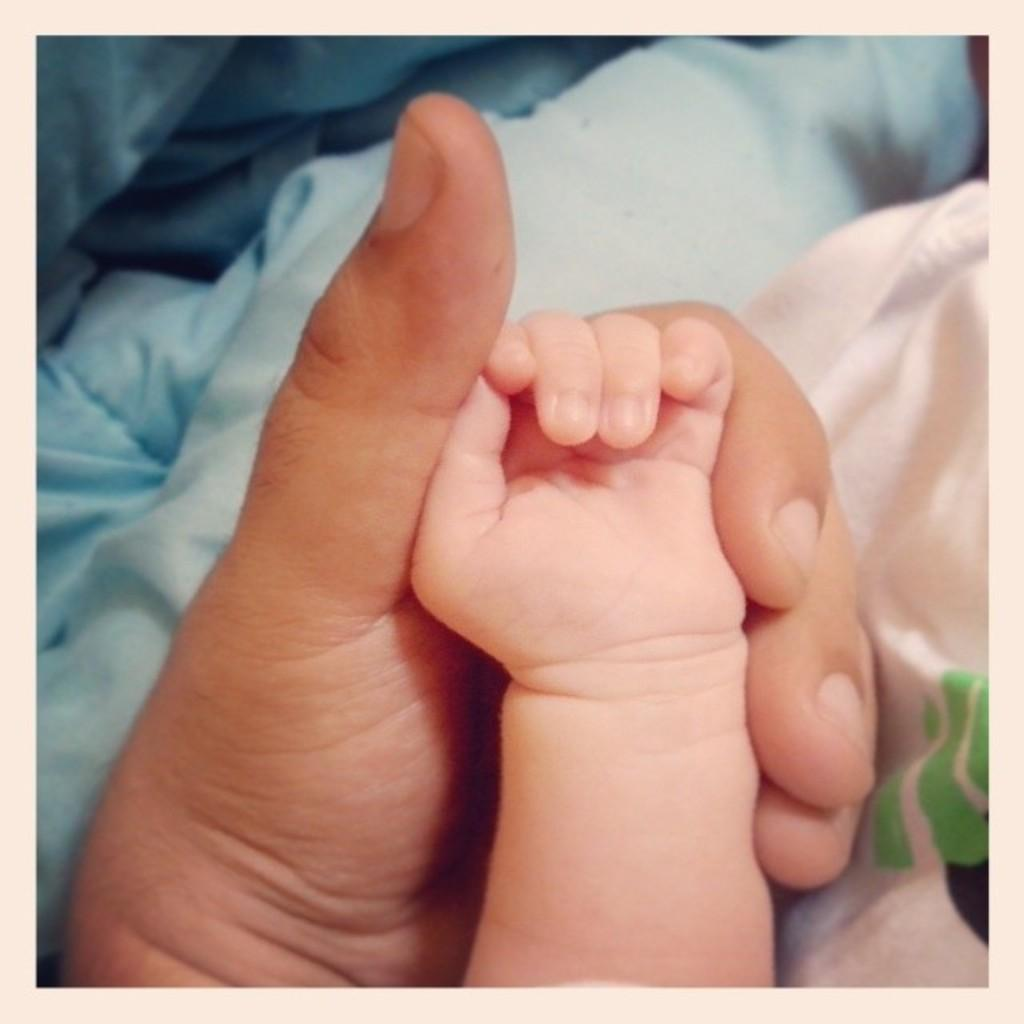What is the person in the image doing with their hand? The person is holding a child's hand in the image. What can be seen on the bed in the image? There is a white-colored bed sheet in the image. What type of plane can be seen flying over the geese in the image? There is no plane or geese present in the image; it only features a person holding a child's hand and a white-colored bed sheet. 